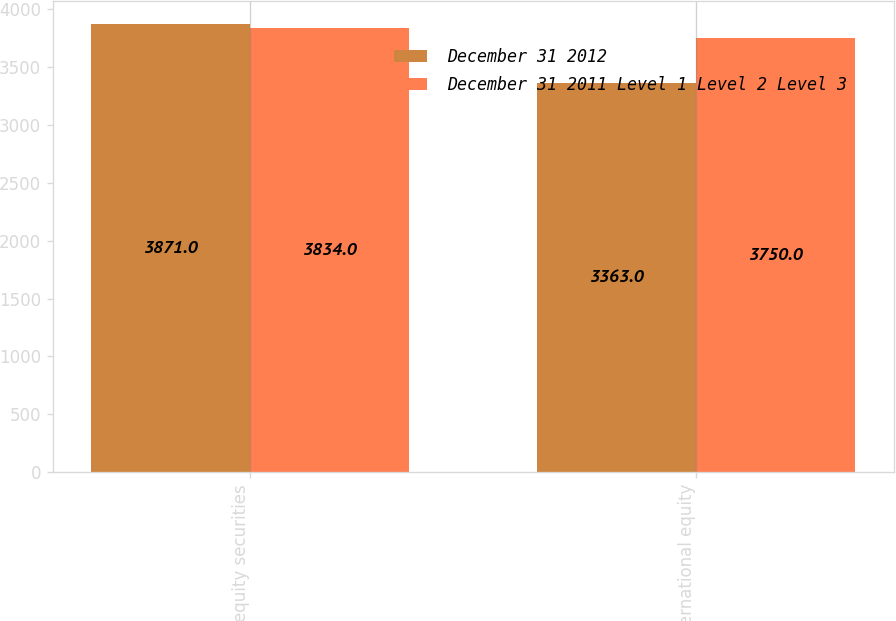Convert chart to OTSL. <chart><loc_0><loc_0><loc_500><loc_500><stacked_bar_chart><ecel><fcel>US equity securities<fcel>International equity<nl><fcel>December 31 2012<fcel>3871<fcel>3363<nl><fcel>December 31 2011 Level 1 Level 2 Level 3<fcel>3834<fcel>3750<nl></chart> 